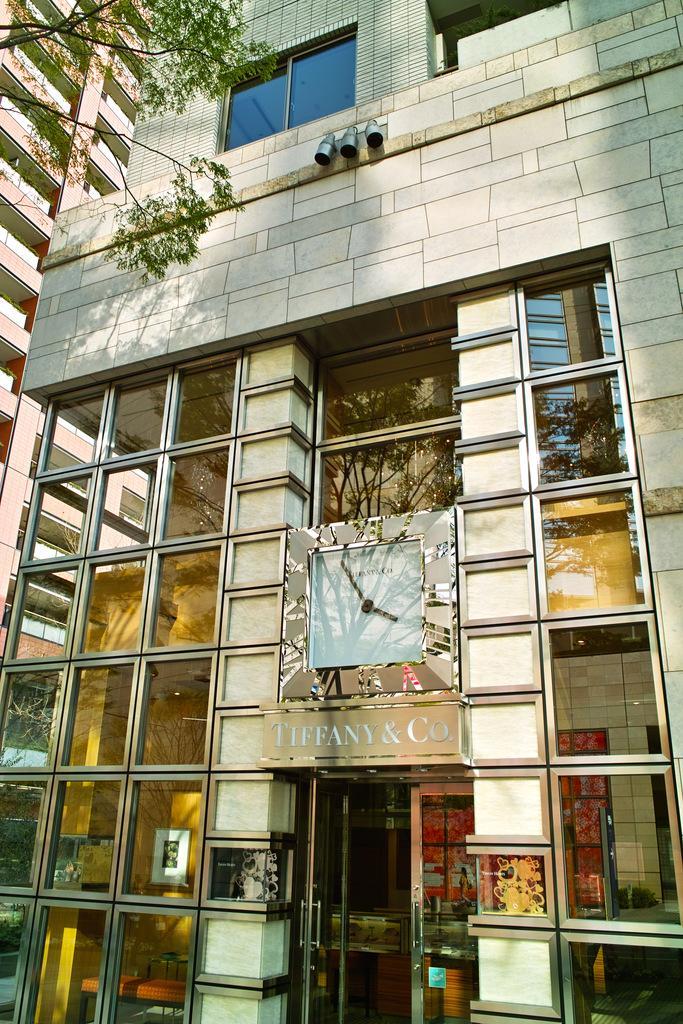In one or two sentences, can you explain what this image depicts? In this image I can see the building and there is a clock to the building. And I can see another building to the left. There are frames to the wall inside the building. I can also see the tree to the left. 